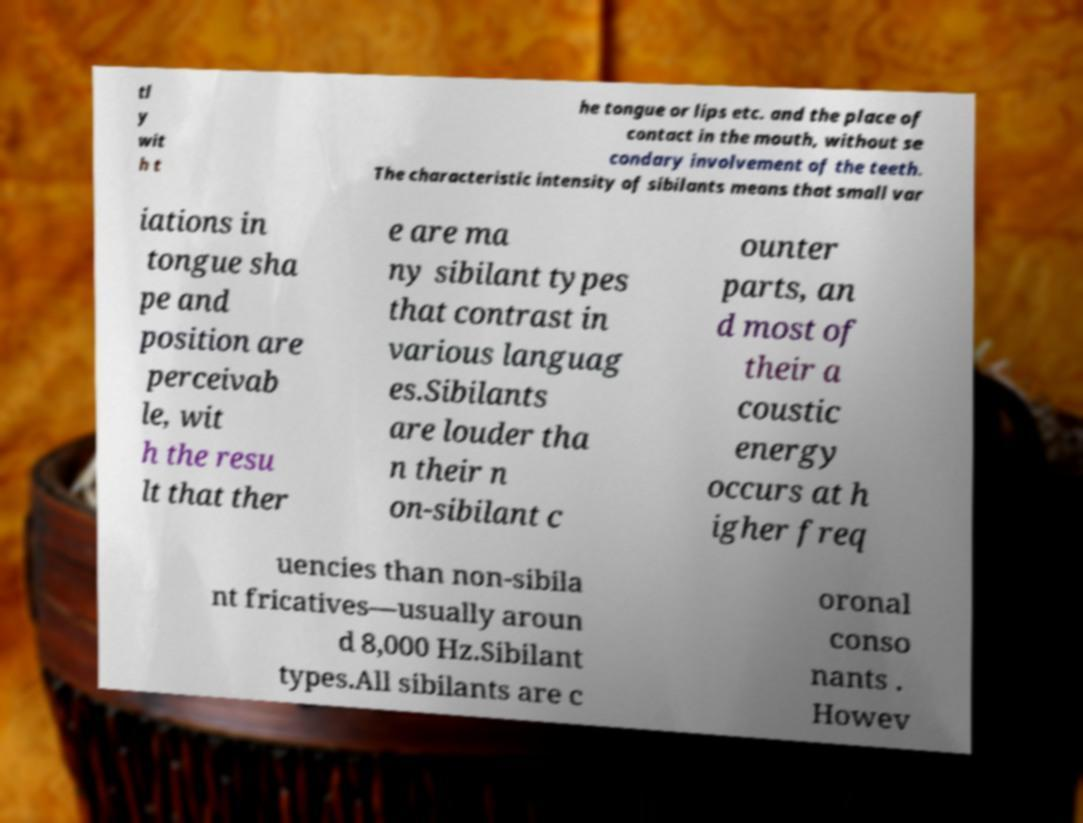Please read and relay the text visible in this image. What does it say? tl y wit h t he tongue or lips etc. and the place of contact in the mouth, without se condary involvement of the teeth. The characteristic intensity of sibilants means that small var iations in tongue sha pe and position are perceivab le, wit h the resu lt that ther e are ma ny sibilant types that contrast in various languag es.Sibilants are louder tha n their n on-sibilant c ounter parts, an d most of their a coustic energy occurs at h igher freq uencies than non-sibila nt fricatives—usually aroun d 8,000 Hz.Sibilant types.All sibilants are c oronal conso nants . Howev 